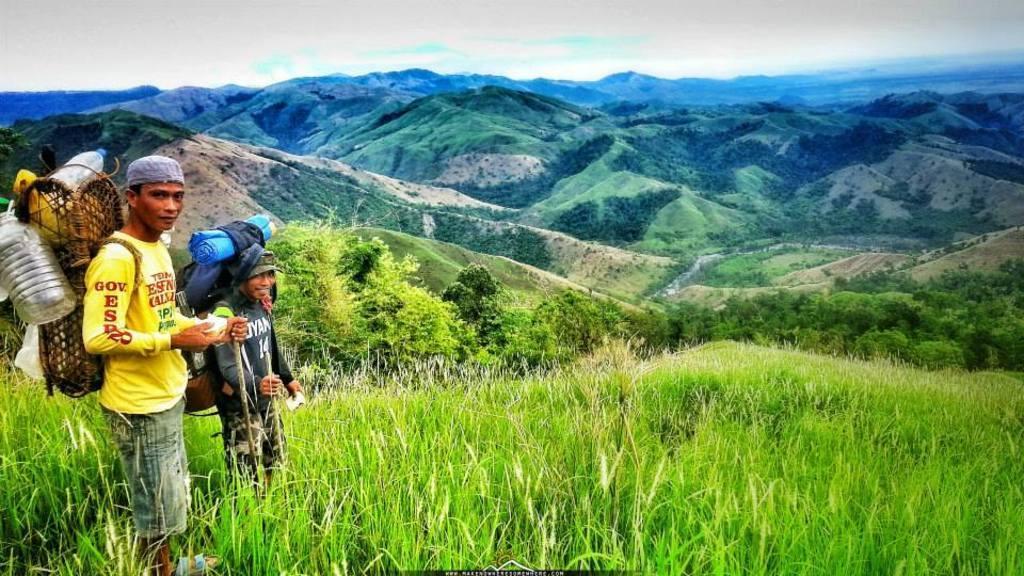Please provide a concise description of this image. In the image on the left side there are two men standing and holding sticks in their hands. And also they are carrying few objects. At the bottom of the image there is grass. In the background there are hills and trees. At the top of the image there is sky. 